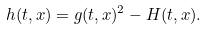Convert formula to latex. <formula><loc_0><loc_0><loc_500><loc_500>h ( t , x ) = g ( t , x ) ^ { 2 } - H ( t , x ) .</formula> 